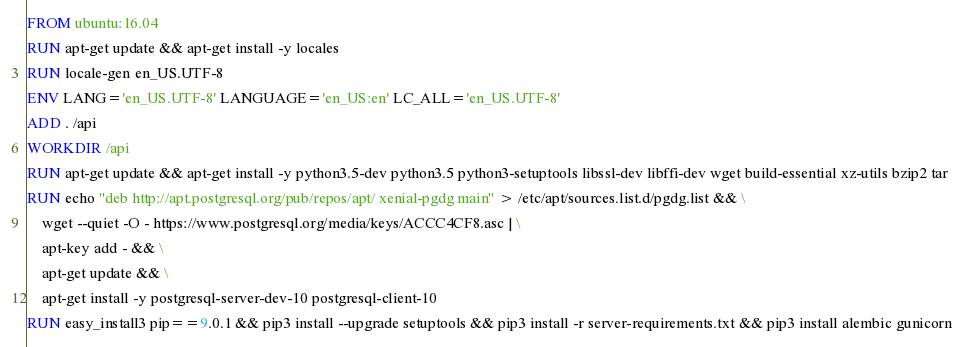Convert code to text. <code><loc_0><loc_0><loc_500><loc_500><_Dockerfile_>FROM ubuntu:16.04
RUN apt-get update && apt-get install -y locales
RUN locale-gen en_US.UTF-8
ENV LANG='en_US.UTF-8' LANGUAGE='en_US:en' LC_ALL='en_US.UTF-8'
ADD . /api
WORKDIR /api
RUN apt-get update && apt-get install -y python3.5-dev python3.5 python3-setuptools libssl-dev libffi-dev wget build-essential xz-utils bzip2 tar
RUN echo "deb http://apt.postgresql.org/pub/repos/apt/ xenial-pgdg main" > /etc/apt/sources.list.d/pgdg.list && \
	wget --quiet -O - https://www.postgresql.org/media/keys/ACCC4CF8.asc | \
	apt-key add - && \ 
	apt-get update && \
	apt-get install -y postgresql-server-dev-10 postgresql-client-10
RUN easy_install3 pip==9.0.1 && pip3 install --upgrade setuptools && pip3 install -r server-requirements.txt && pip3 install alembic gunicorn 
</code> 